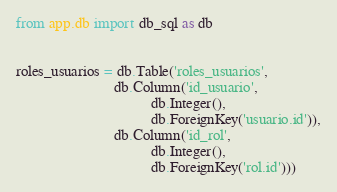<code> <loc_0><loc_0><loc_500><loc_500><_Python_>from app.db import db_sql as db


roles_usuarios = db.Table('roles_usuarios',
                          db.Column('id_usuario',
                                    db.Integer(),
                                    db.ForeignKey('usuario.id')),
                          db.Column('id_rol',
                                    db.Integer(),
                                    db.ForeignKey('rol.id')))
</code> 